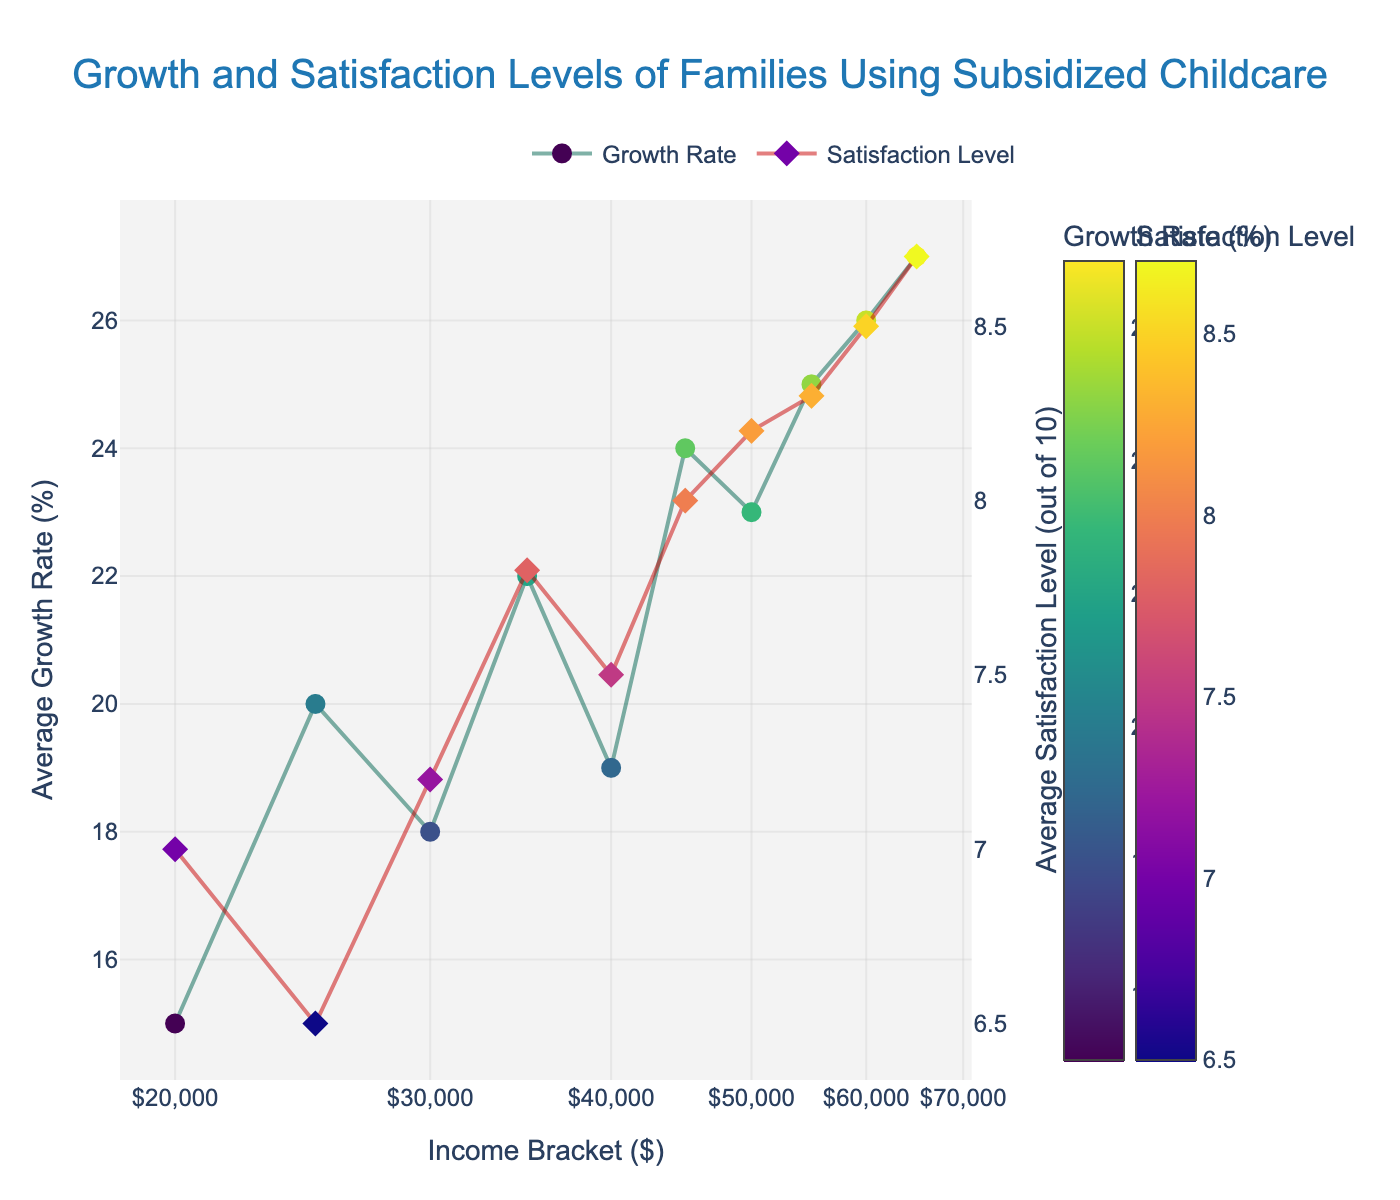What's the title of the scatter plot? The title can be observed at the top of the plot. Here, the title is "Growth and Satisfaction Levels of Families Using Subsidized Childcare".
Answer: Growth and Satisfaction Levels of Families Using Subsidized Childcare What does the x-axis represent, and what scale is it using? The x-axis represents the "Income Bracket ($)", as indicated by the label, and it is using a log scale, evident by the varying distances between the income bracket values which increase exponentially.
Answer: Income Bracket ($), log scale What are the two variables plotted on the y-axes? There are two y-axes corresponding to two variables: The left y-axis represents the "Average Growth Rate (%)" and the right y-axis represents the "Average Satisfaction Level (out of 10)".
Answer: Average Growth Rate (%), Average Satisfaction Level (out of 10) Which income bracket has the highest average satisfaction level? By examining the plot closely, the highest average satisfaction level of 8.7 can be found at the income bracket of $65,000.
Answer: $65,000 How does the average growth rate change as income bracket increases? By observing the overall trend of the markers and lines for the growth rate, it generally increases as the income bracket increases, with a few fluctuations.
Answer: Generally increases What is the average satisfaction level at an income bracket of $50000? By locating the $50,000 income bracket on the x-axis and tracing it vertically to the satisfaction level line, the average satisfaction level is found to be 8.2.
Answer: 8.2 Compare the average growth rate between the income brackets of $30,000 and $60,000. The plot indicates that at $30,000 the average growth rate is 18%, and at $60,000 it is 26%, showing that the growth rate is higher at $60,000.
Answer: 26% at $60,000, 18% at $30,000 What can you infer about the relationship between income brackets and the average satisfaction level? By examining the trend of the markers and lines for satisfaction levels, it appears that as the income bracket increases, the average satisfaction level also tends to increase, indicating a positive correlation.
Answer: Positive correlation What income bracket corresponds to a growth rate of 22%? By tracing the 22% growth rate on the left y-axis horizontally to where it intersects with the growth rate line, the corresponding income bracket is found to be $35,000.
Answer: $35,000 What visual cues are used to distinguish between the growth rate and satisfaction levels on the plot? Different colors, shapes, and position of the markers are used: Growth Rate markers are colored with a Viridis colorscale and have a circle shape, while Satisfaction Level markers are colored with a Plasma colorscale and have a diamond shape. Additionally, the Growth Rate is plotted against the left y-axis, whereas Satisfaction Level is plotted against the right y-axis.
Answer: Colors and shapes 